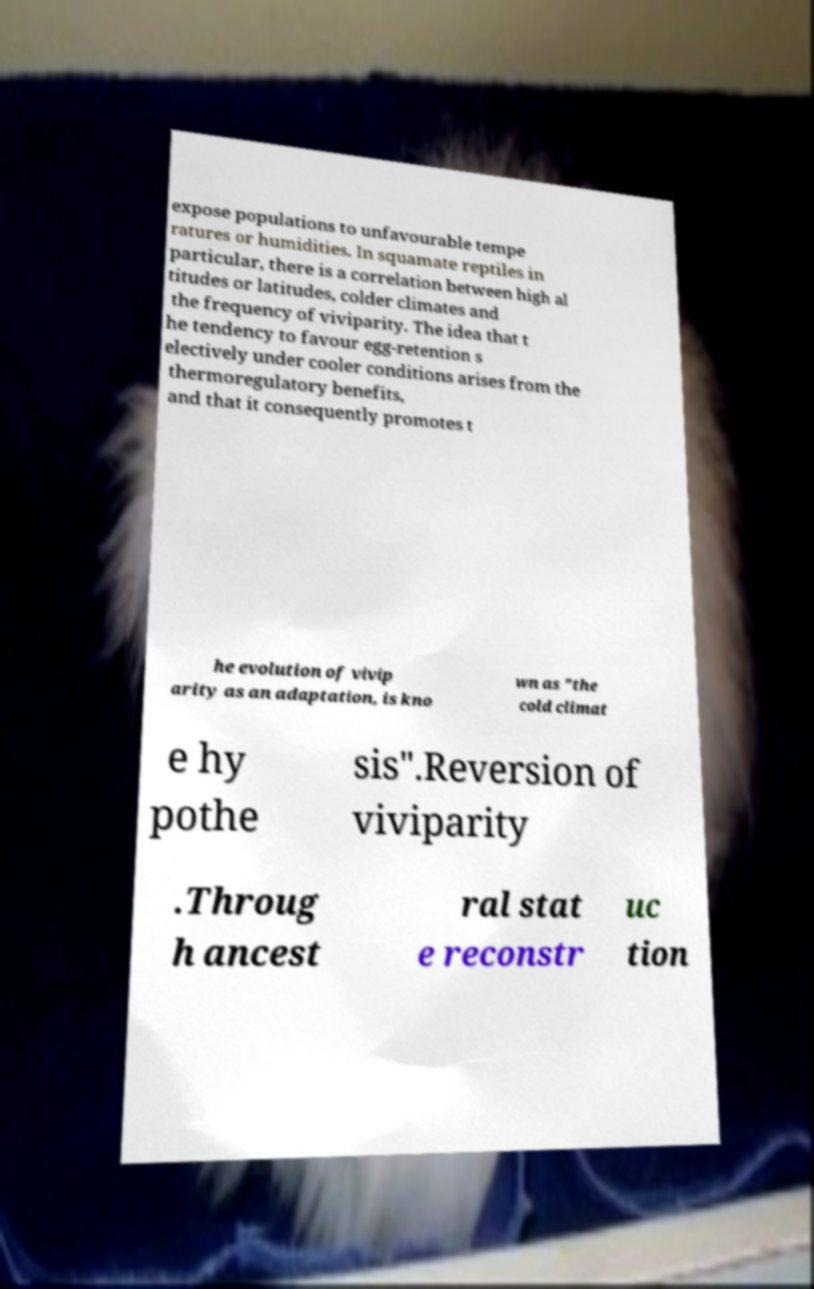Could you extract and type out the text from this image? expose populations to unfavourable tempe ratures or humidities. In squamate reptiles in particular, there is a correlation between high al titudes or latitudes, colder climates and the frequency of viviparity. The idea that t he tendency to favour egg-retention s electively under cooler conditions arises from the thermoregulatory benefits, and that it consequently promotes t he evolution of vivip arity as an adaptation, is kno wn as "the cold climat e hy pothe sis".Reversion of viviparity .Throug h ancest ral stat e reconstr uc tion 